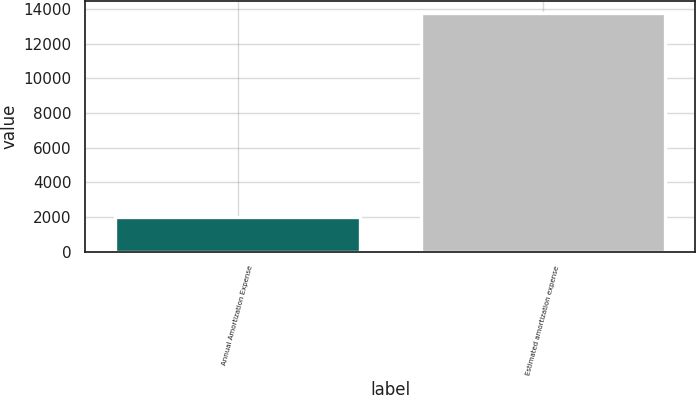<chart> <loc_0><loc_0><loc_500><loc_500><bar_chart><fcel>Annual Amortization Expense<fcel>Estimated amortization expense<nl><fcel>2019<fcel>13792<nl></chart> 